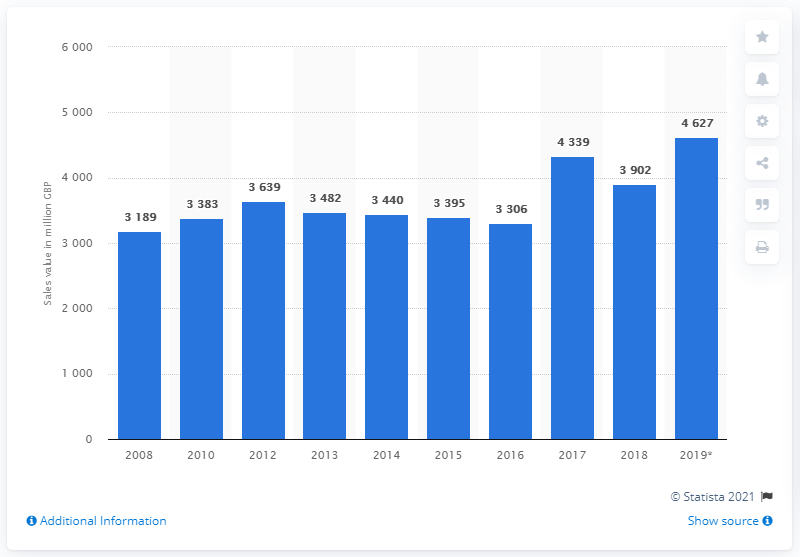List a handful of essential elements in this visual. In the United Kingdom in 2019, the value of rusks and biscuits was 4,627. In the year 2008, the total sales value of rusks, biscuits, and preserved pastry goods in the United Kingdom reached a significant milestone. 